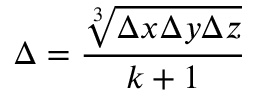<formula> <loc_0><loc_0><loc_500><loc_500>\Delta = \frac { \sqrt { [ } 3 ] { \Delta x \Delta y \Delta z } } { k + 1 }</formula> 